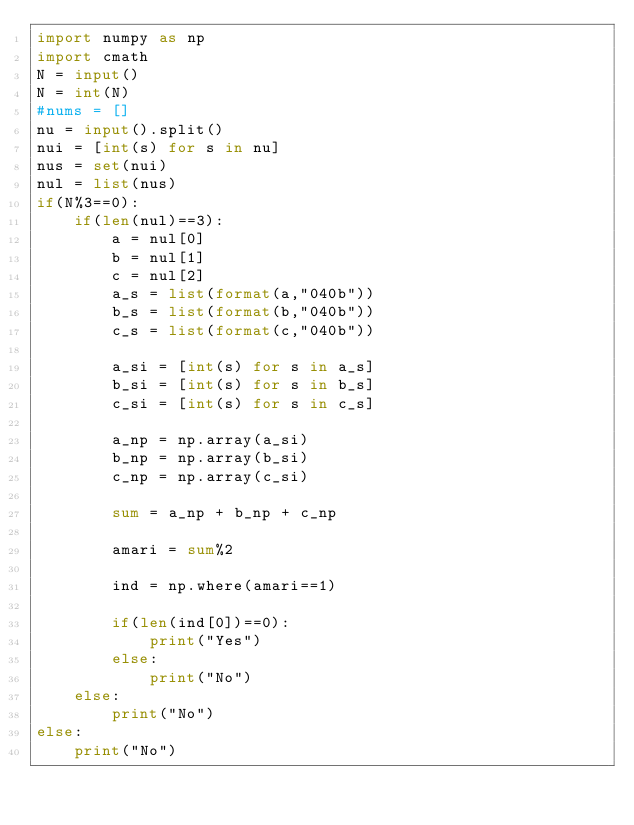Convert code to text. <code><loc_0><loc_0><loc_500><loc_500><_Python_>import numpy as np
import cmath
N = input()
N = int(N)
#nums = []
nu = input().split()
nui = [int(s) for s in nu]
nus = set(nui)
nul = list(nus)
if(N%3==0):
    if(len(nul)==3):
        a = nul[0]
        b = nul[1]
        c = nul[2]
        a_s = list(format(a,"040b"))
        b_s = list(format(b,"040b"))
        c_s = list(format(c,"040b"))
        
        a_si = [int(s) for s in a_s]
        b_si = [int(s) for s in b_s]
        c_si = [int(s) for s in c_s]
        
        a_np = np.array(a_si)
        b_np = np.array(b_si)
        c_np = np.array(c_si)
        
        sum = a_np + b_np + c_np
        
        amari = sum%2
        
        ind = np.where(amari==1)
        
        if(len(ind[0])==0):
            print("Yes")
        else:
            print("No")
    else:
        print("No")
else:
    print("No")</code> 